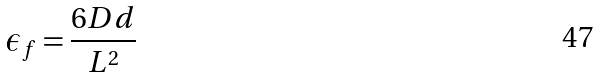<formula> <loc_0><loc_0><loc_500><loc_500>\epsilon _ { f } = \frac { 6 D d } { L ^ { 2 } }</formula> 